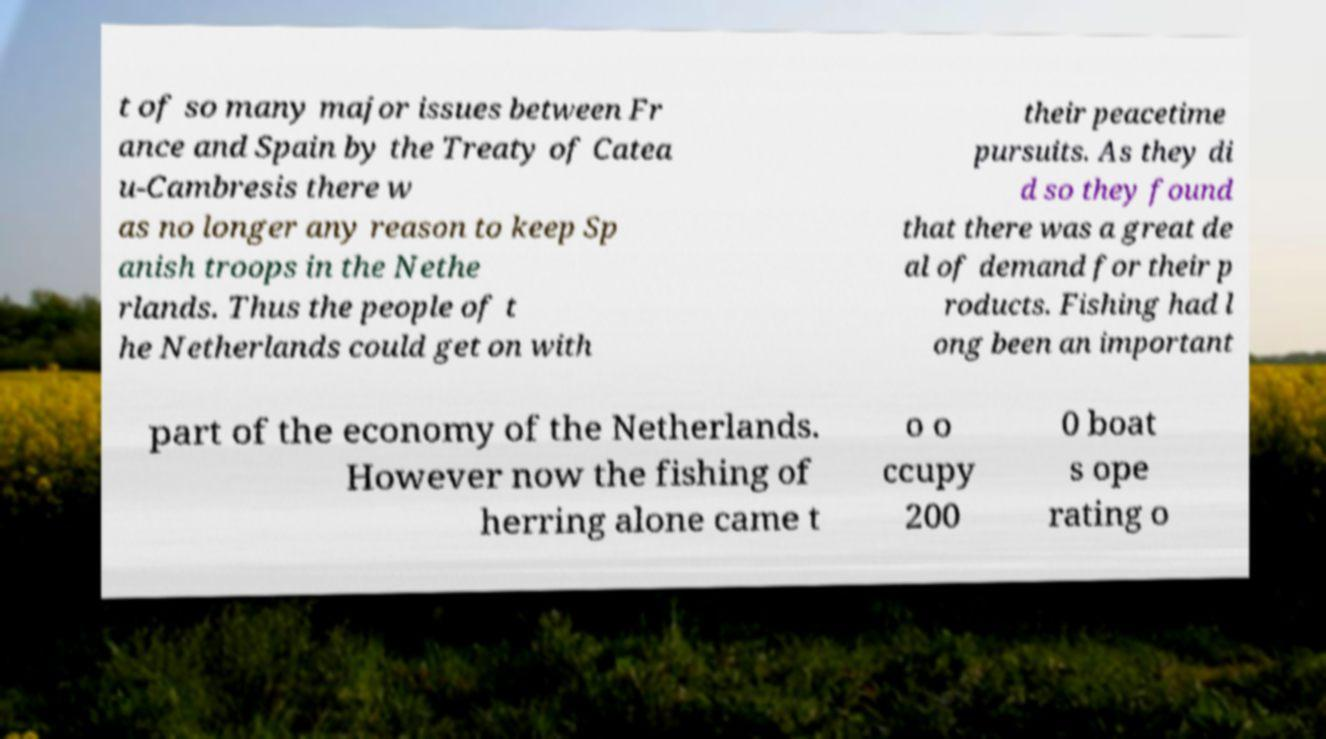Can you accurately transcribe the text from the provided image for me? t of so many major issues between Fr ance and Spain by the Treaty of Catea u-Cambresis there w as no longer any reason to keep Sp anish troops in the Nethe rlands. Thus the people of t he Netherlands could get on with their peacetime pursuits. As they di d so they found that there was a great de al of demand for their p roducts. Fishing had l ong been an important part of the economy of the Netherlands. However now the fishing of herring alone came t o o ccupy 200 0 boat s ope rating o 